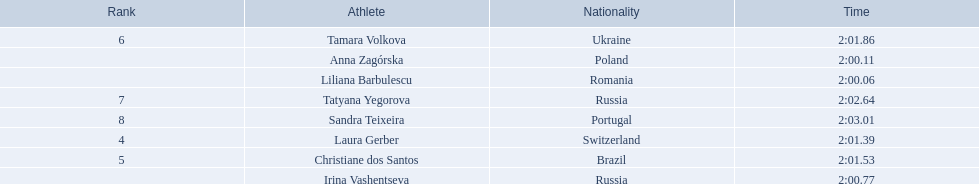Who were the athletes? Liliana Barbulescu, 2:00.06, Anna Zagórska, 2:00.11, Irina Vashentseva, 2:00.77, Laura Gerber, 2:01.39, Christiane dos Santos, 2:01.53, Tamara Volkova, 2:01.86, Tatyana Yegorova, 2:02.64, Sandra Teixeira, 2:03.01. Who received 2nd place? Anna Zagórska, 2:00.11. What was her time? 2:00.11. 